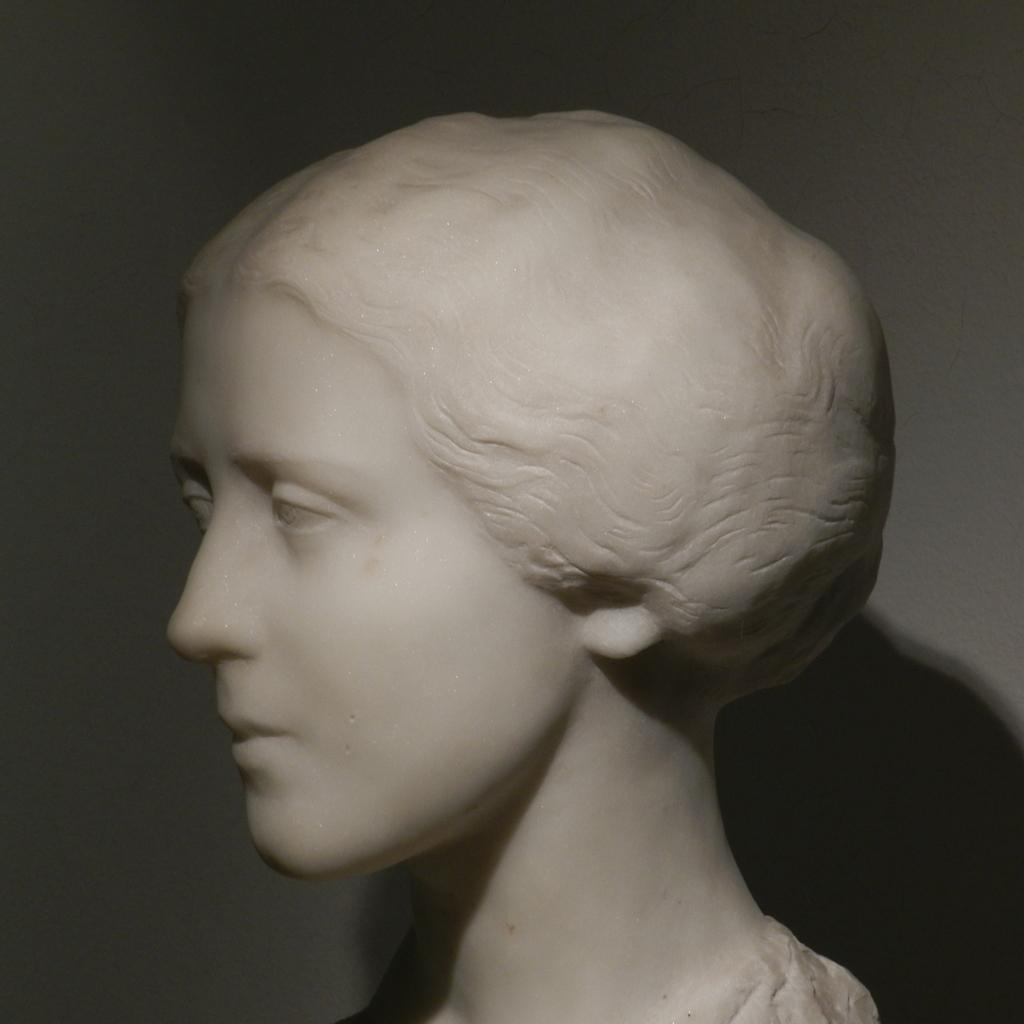What is the main subject in the image? There is a statue in the image. What color is the statue? The statue is in white color. What can be seen in the background of the image? The background of the image is white color. How many firemen are present in the image? There are no firemen present in the image; it features a statue. What type of dogs can be seen interacting with the statue in the image? There are no dogs present in the image, and therefore no such interaction can be observed. 